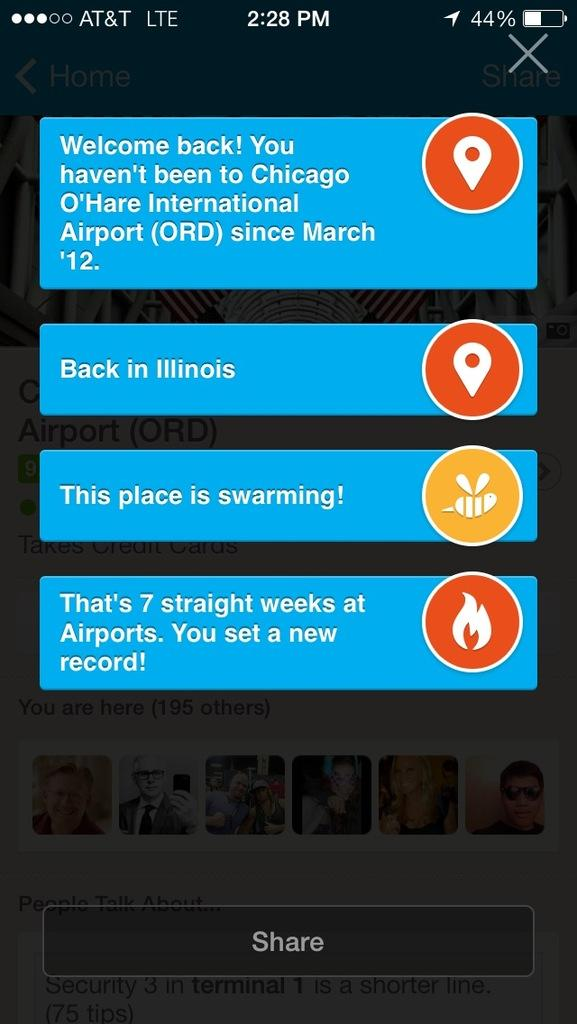<image>
Summarize the visual content of the image. A screenshot of a cell phone shows a text conversation about Chicago, IL and being in airports a lot. 